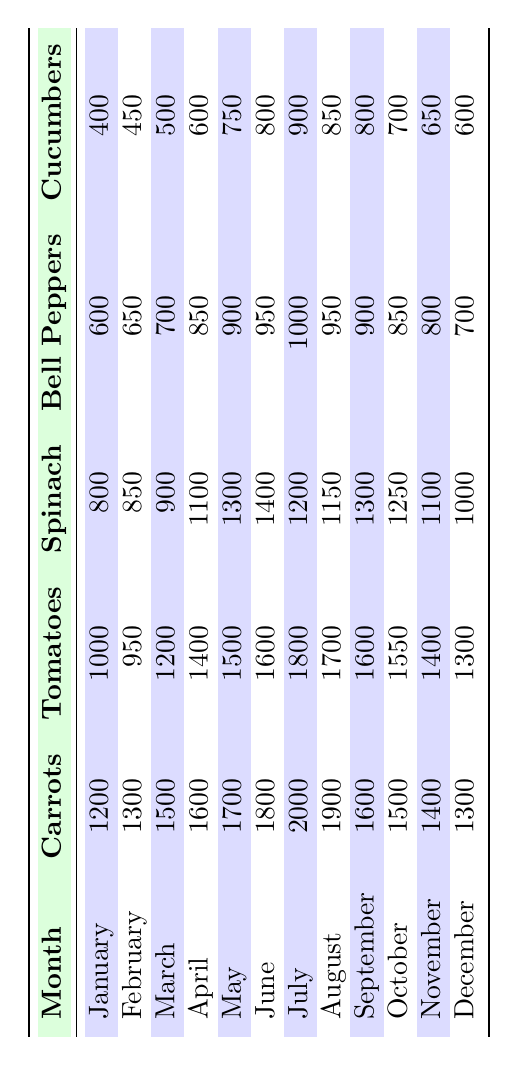What was the total sales of organic carrots in June? Looking at the row for June, the value for organic carrots is given as 1800. Therefore, the total sales of organic carrots in June is 1800.
Answer: 1800 Which month had the highest sales of organic tomatoes? By examining the table, July has the highest sales of organic tomatoes, with a value of 1800.
Answer: July What is the average sales of cucumbers from January to March? The sales figures for cucumbers from January to March are 400, 450, and 500 respectively. Adding these gives 400 + 450 + 500 = 1350. Since there are 3 months, the average is 1350 / 3 = 450.
Answer: 450 Did organic spinach sales increase every month? We can check the sales figures for organic spinach: January (800), February (850), March (900), April (1100), May (1300), June (1400), July (1200), August (1150), September (1300), October (1250), November (1100), December (1000). Observing these, there are months (July, August, October, November, and December) where the sales decreased. Thus, the sales did not increase every month.
Answer: No What was the difference in sales of bell peppers between the highest and lowest month? The highest sales for bell peppers is in July (1000), and the lowest is in December (700). The difference is 1000 - 700 = 300. Therefore, the difference in sales of bell peppers between these months is 300.
Answer: 300 In which month do organic tomatoes have sales equal to the average for the entire year? First, we calculate the total sales of organic tomatoes for the year: 1000 + 950 + 1200 + 1400 + 1500 + 1600 + 1800 + 1700 + 1600 + 1550 + 1400 + 1300 = 16800. Next, the average is 16800 / 12 = 1400. Looking at the monthly figures, both April and November have sales of 1400. Thus, both months match the average.
Answer: April and November Which type of organic produce had the greatest total sales for the year? To determine this, we will sum the sales for each type: For carrots: 1200 + 1300 + 1500 + 1600 + 1700 + 1800 + 2000 + 1900 + 1600 + 1500 + 1400 + 1300 = 18500; For tomatoes: 1000 + 950 + 1200 + 1400 + 1500 + 1600 + 1800 + 1700 + 1600 + 1550 + 1400 + 1300 = 16800; For spinach: 800 + 850 + 900 + 1100 + 1300 + 1400 + 1200 + 1150 + 1300 + 1250 + 1100 + 1000 = 12800; For bell peppers: 600 + 650 + 700 + 850 + 900 + 950 + 1000 + 950 + 900 + 850 + 800 + 700 = 11000; For cucumbers: 400 + 450 + 500 + 600 + 750 + 800 + 900 + 850 + 800 + 700 + 650 + 600 = 6650. The greatest total sales are for organic carrots at 18500.
Answer: Organic carrots What was the percentage increase in sales of organic cucumbers from May to June? The sales of organic cucumbers in May is 750 and in June is 800. The increase is 800 - 750 = 50. To find the percentage increase: (50 / 750) * 100 = 6.67%.
Answer: 6.67% What was the trend in sales of organic spinach from March to June? The sales figures for organic spinach from March to June are: March (900), April (1100), May (1300), and June (1400). Each month shows an increase: 900 to 1100 (200 increase), 1100 to 1300 (200 increase), and 1300 to 1400 (100 increase). Thus, the trend shows a consistent increase over these months.
Answer: Increasing Which month had a drop in organic carrot sales compared to the previous month? By reviewing the sales data, in September, sales of organic carrots dropped to 1600 from 2000 in July, marking a decrease. Thus, September is the month that experienced a drop compared to July.
Answer: September 